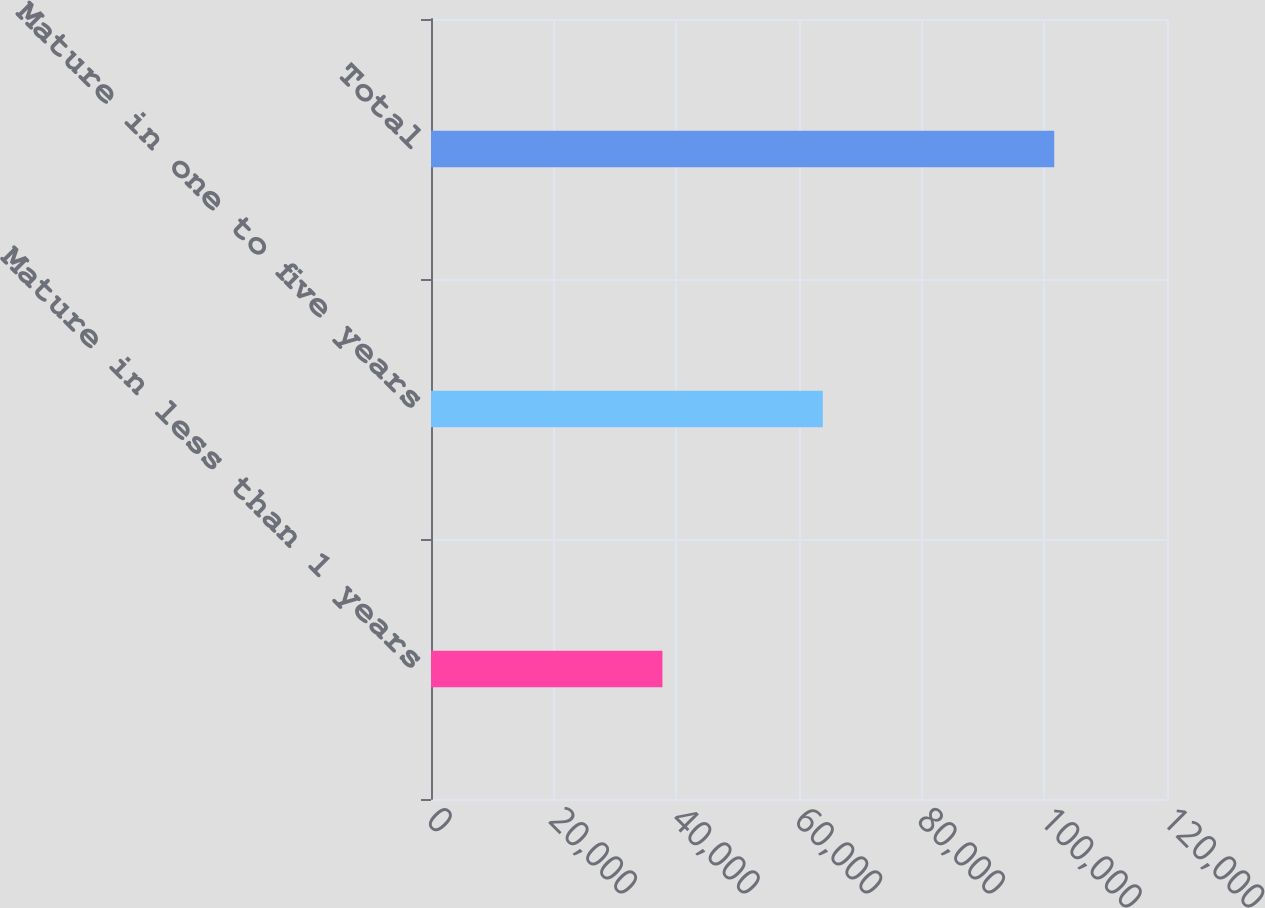<chart> <loc_0><loc_0><loc_500><loc_500><bar_chart><fcel>Mature in less than 1 years<fcel>Mature in one to five years<fcel>Total<nl><fcel>37735<fcel>63879<fcel>101614<nl></chart> 